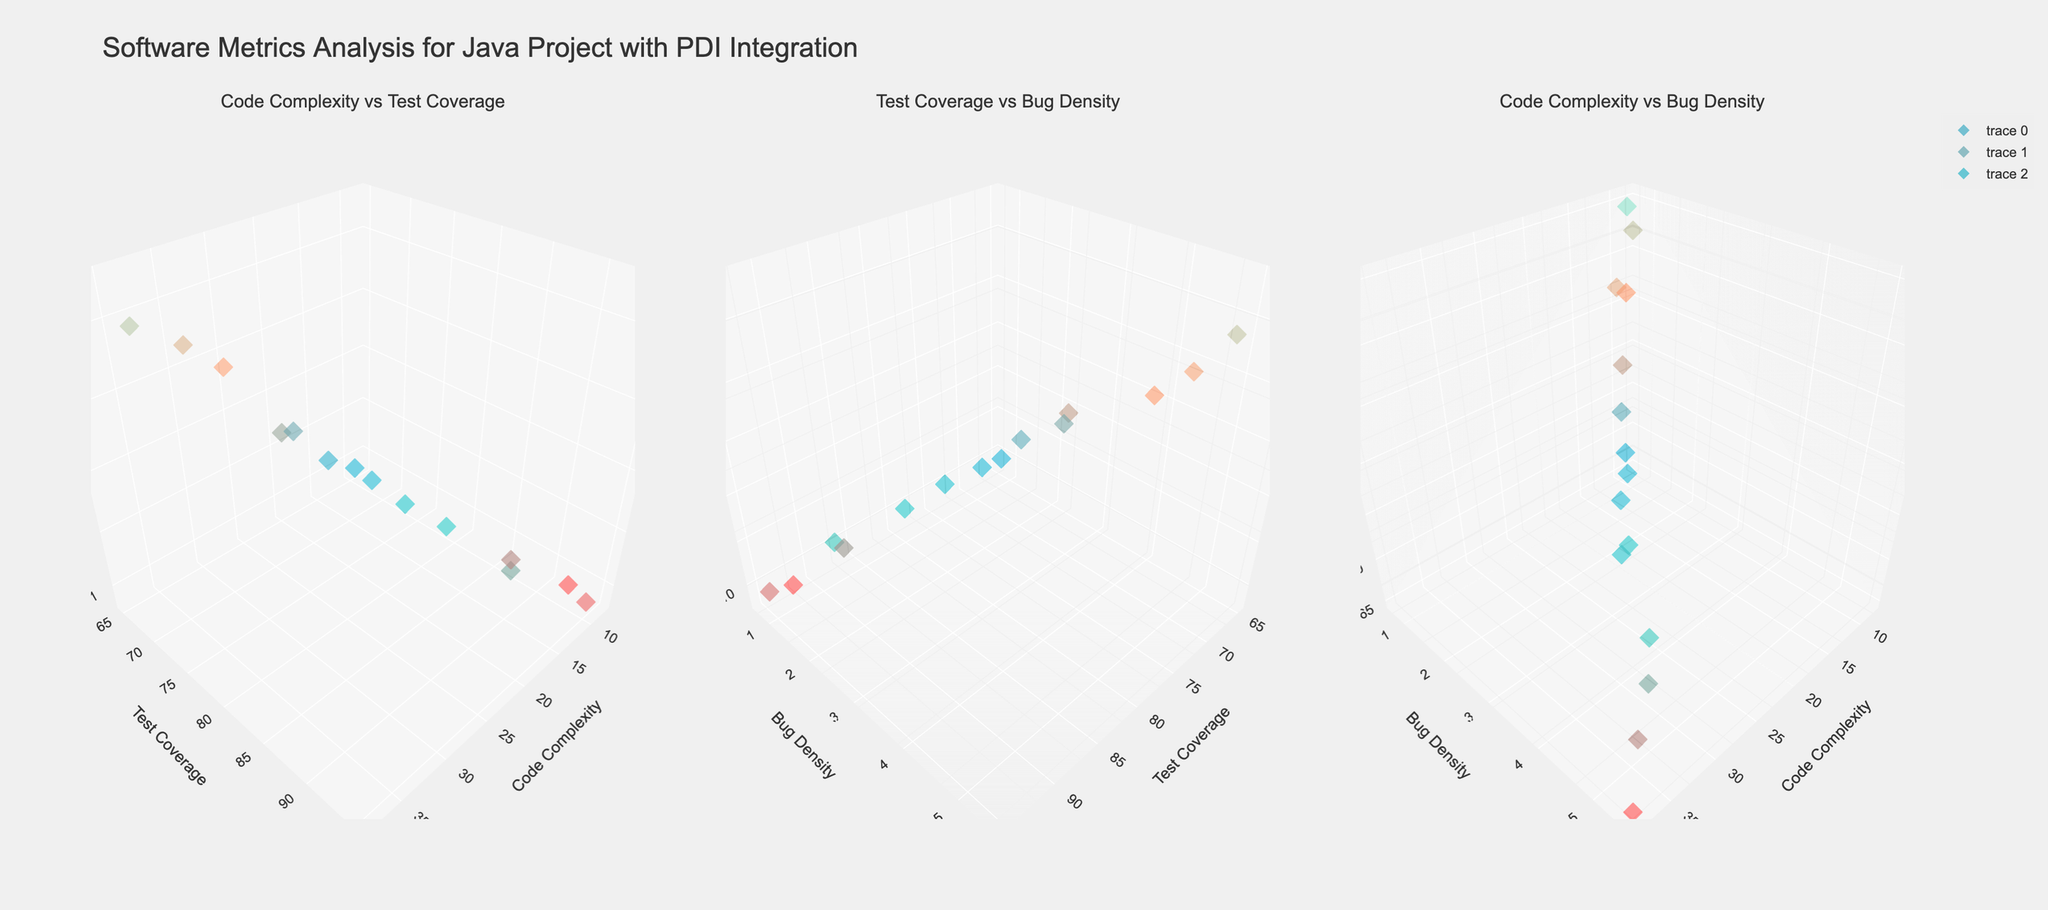How many modules have their code complexity plotted on the x-axis in the first subplot? The first subplot plots code complexity on the x-axis. Counting all the data points plotted, there are 15 modules.
Answer: 15 Which module shows the highest bug density? By examining the data points' z-axis in each subplot, ClusteringEngine has the highest bug density of 5.5.
Answer: ClusteringEngine What's the average code complexity of all modules? Sum the code complexities: 25 + 18 + 30 + 22 + 28 + 15 + 10 + 35 + 20 + 32 + 12 + 8 + 26 + 23 + 38 = 342. Divide by the number of modules (15): 342 / 15 = 22.8.
Answer: 22.8 Which module has the highest test coverage and what is its bug density? SchedulerService has the highest test coverage with 90%, indicated in the subplots. Its bug density is 1.5.
Answer: SchedulerService; 1.5 Is there a module with more than 30 code complexity and less than 75 test coverage? The modules DataIntegration (25, 78) and UserInterface (35, 68) fit. Only UserInterface has more than 30 code complexity and less than 75 test coverage.
Answer: UserInterface What is the difference in bug density between the module with the highest test coverage and the module with the lowest? The highest test coverage is SchedulerService (90%) and the lowest is UserInterface (68%). SchedulerService's bug density is 1.5 and UserInterface's is 5.1. The difference is 5.1 - 1.5 = 3.6.
Answer: 3.6 Between DataIntegration and XMLParser, which has lower bug density? DataIntegration has a bug density of 3.2, whereas XMLParser has 2.8, which is lower.
Answer: XMLParser In the second subplot, what axis represents code complexity? By looking at the axis titles, the z-axis represents code complexity in the second subplot (Test Coverage vs Bug Density vs Code Complexity).
Answer: z-axis What is the median test coverage of the modules? The test coverages are {68, 70, 72, 75, 76, 78, 79, 80, 82, 85, 88, 90, 92, 95}. With 15 values, the middle one is 80.
Answer: 80 Which module has the lowest code complexity and what characteristics does it have in the other two metrics? CacheManager has the lowest code complexity of 8. It has a test coverage of 92% and bug density of 0.7.
Answer: CacheManager; Test Coverage: 92, Bug Density: 0.7 